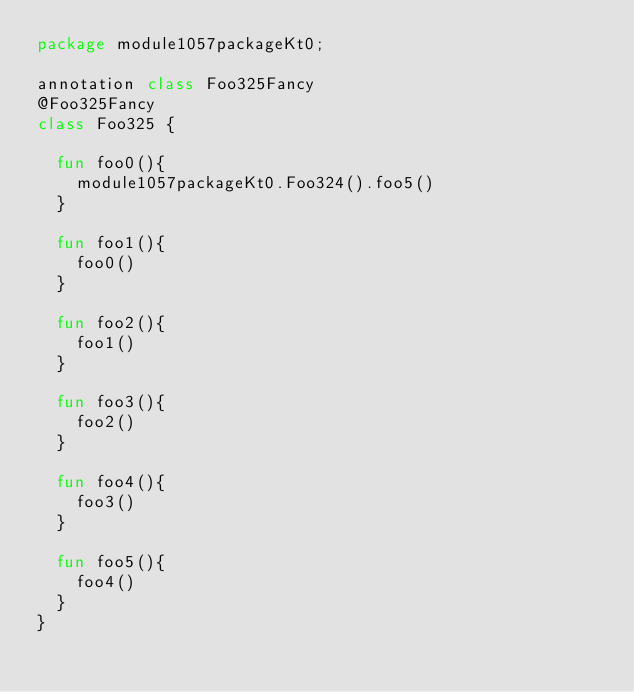Convert code to text. <code><loc_0><loc_0><loc_500><loc_500><_Kotlin_>package module1057packageKt0;

annotation class Foo325Fancy
@Foo325Fancy
class Foo325 {

  fun foo0(){
    module1057packageKt0.Foo324().foo5()
  }

  fun foo1(){
    foo0()
  }

  fun foo2(){
    foo1()
  }

  fun foo3(){
    foo2()
  }

  fun foo4(){
    foo3()
  }

  fun foo5(){
    foo4()
  }
}</code> 